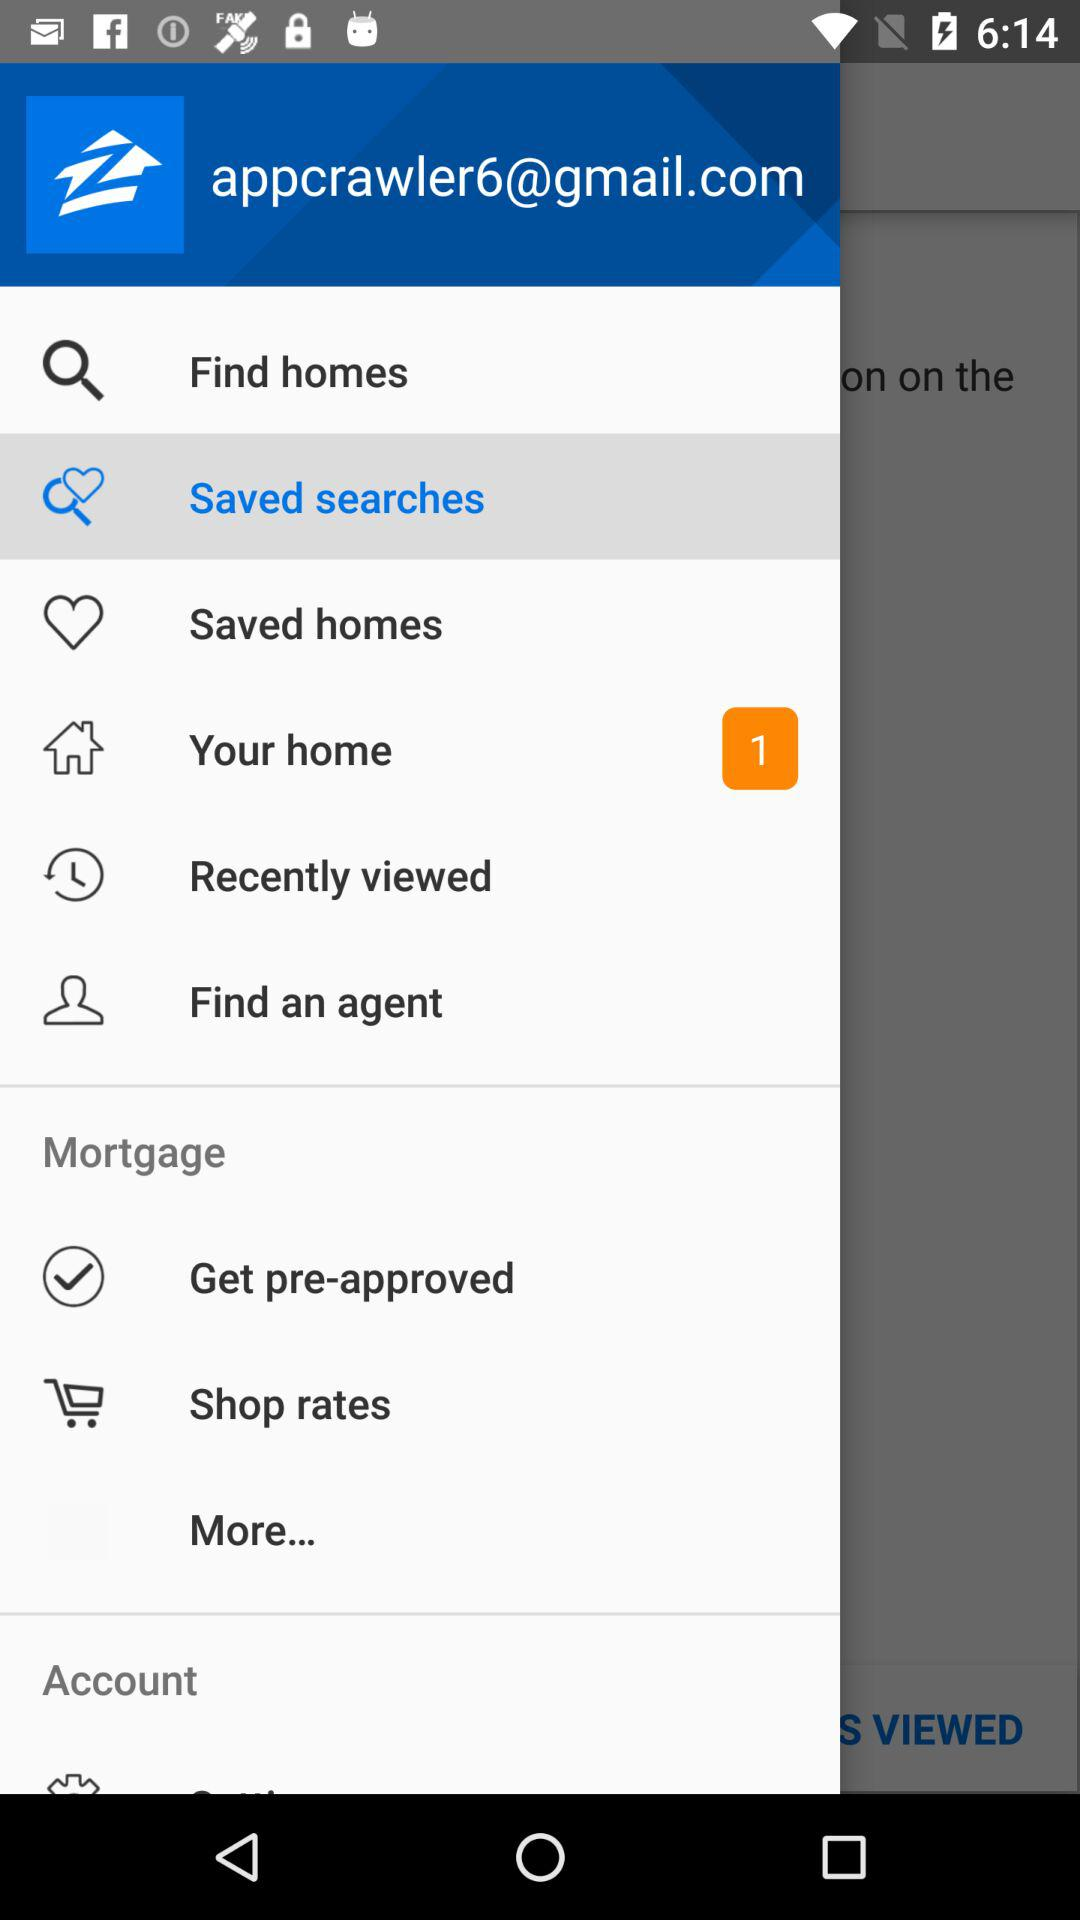How many notifications are in the "Your home" option? There is 1 notification in the "Your home" option. 